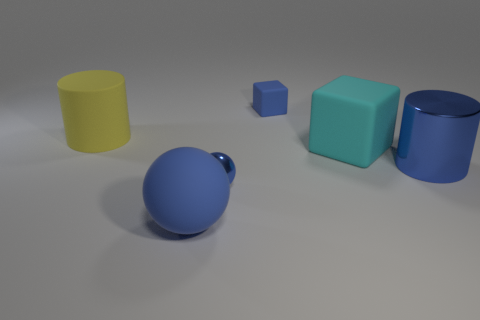Add 2 cubes. How many objects exist? 8 Subtract all cylinders. How many objects are left? 4 Add 1 big matte spheres. How many big matte spheres exist? 2 Subtract 1 cyan blocks. How many objects are left? 5 Subtract all tiny blue spheres. Subtract all shiny spheres. How many objects are left? 4 Add 4 metal objects. How many metal objects are left? 6 